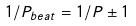<formula> <loc_0><loc_0><loc_500><loc_500>1 / P _ { b e a t } = 1 / P \pm 1</formula> 